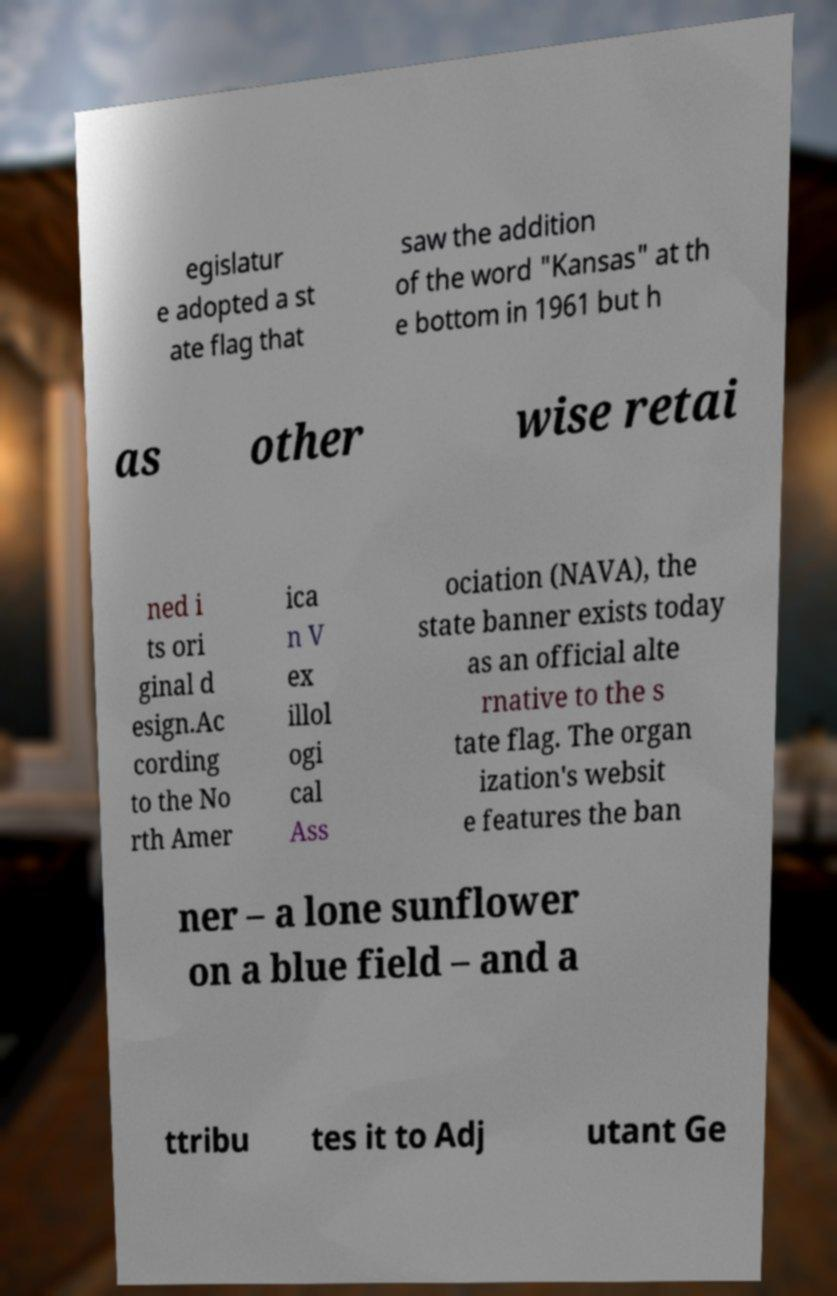Could you extract and type out the text from this image? egislatur e adopted a st ate flag that saw the addition of the word "Kansas" at th e bottom in 1961 but h as other wise retai ned i ts ori ginal d esign.Ac cording to the No rth Amer ica n V ex illol ogi cal Ass ociation (NAVA), the state banner exists today as an official alte rnative to the s tate flag. The organ ization's websit e features the ban ner – a lone sunflower on a blue field – and a ttribu tes it to Adj utant Ge 